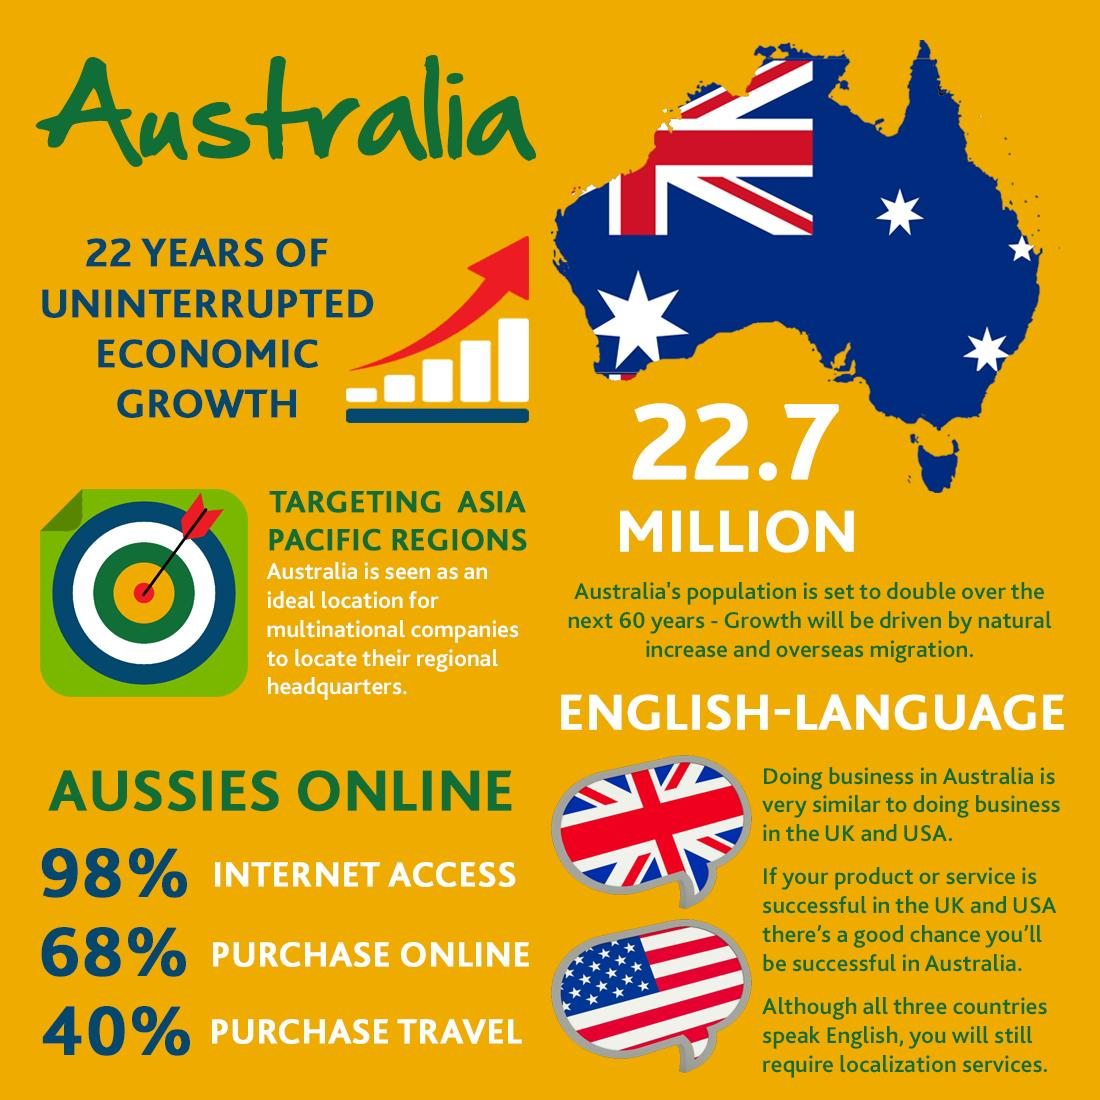Outline some significant characteristics in this image. According to the given statistic, approximately 32% of Australians do not purchase through online platforms. Approximately 2% of Australians do not use the internet. The population of Australia is approximately 22.7 million. According to a recent survey, 60% of Australians do not purchase or travel. 